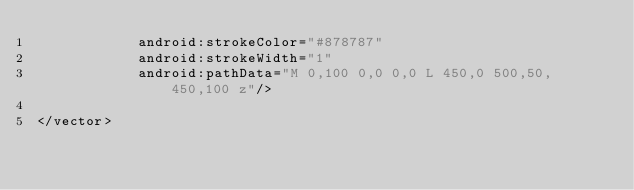Convert code to text. <code><loc_0><loc_0><loc_500><loc_500><_XML_>            android:strokeColor="#878787"
            android:strokeWidth="1"
            android:pathData="M 0,100 0,0 0,0 L 450,0 500,50, 450,100 z"/>

</vector></code> 